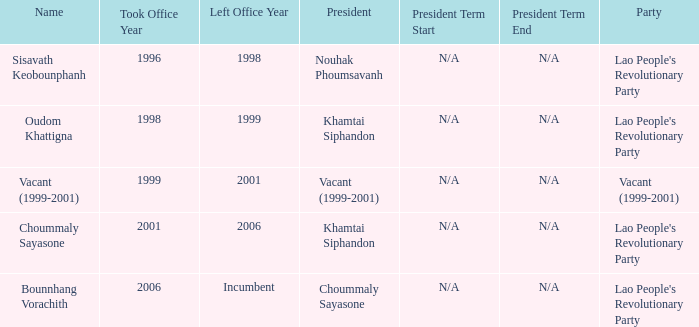What is Party, when Name is Oudom Khattigna? Lao People's Revolutionary Party. 